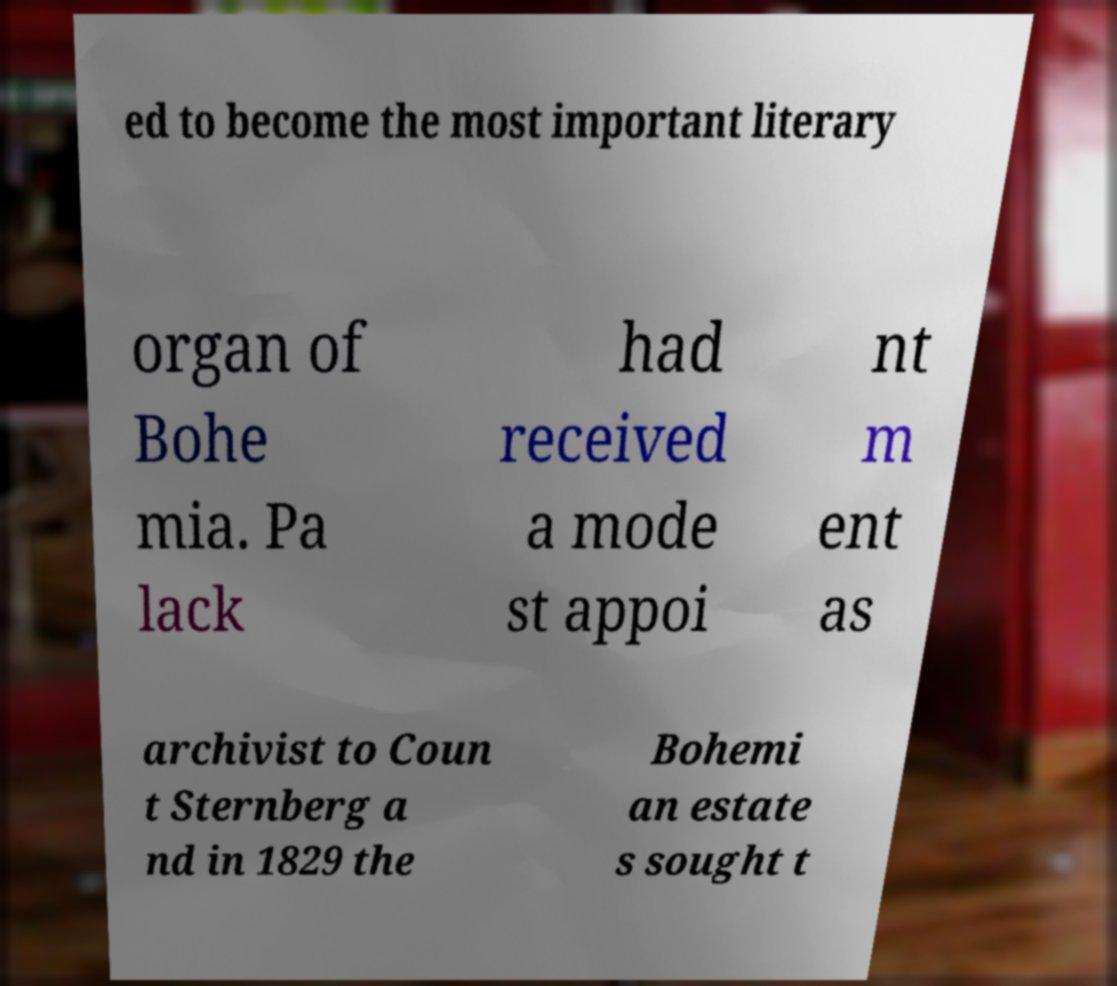Please identify and transcribe the text found in this image. ed to become the most important literary organ of Bohe mia. Pa lack had received a mode st appoi nt m ent as archivist to Coun t Sternberg a nd in 1829 the Bohemi an estate s sought t 